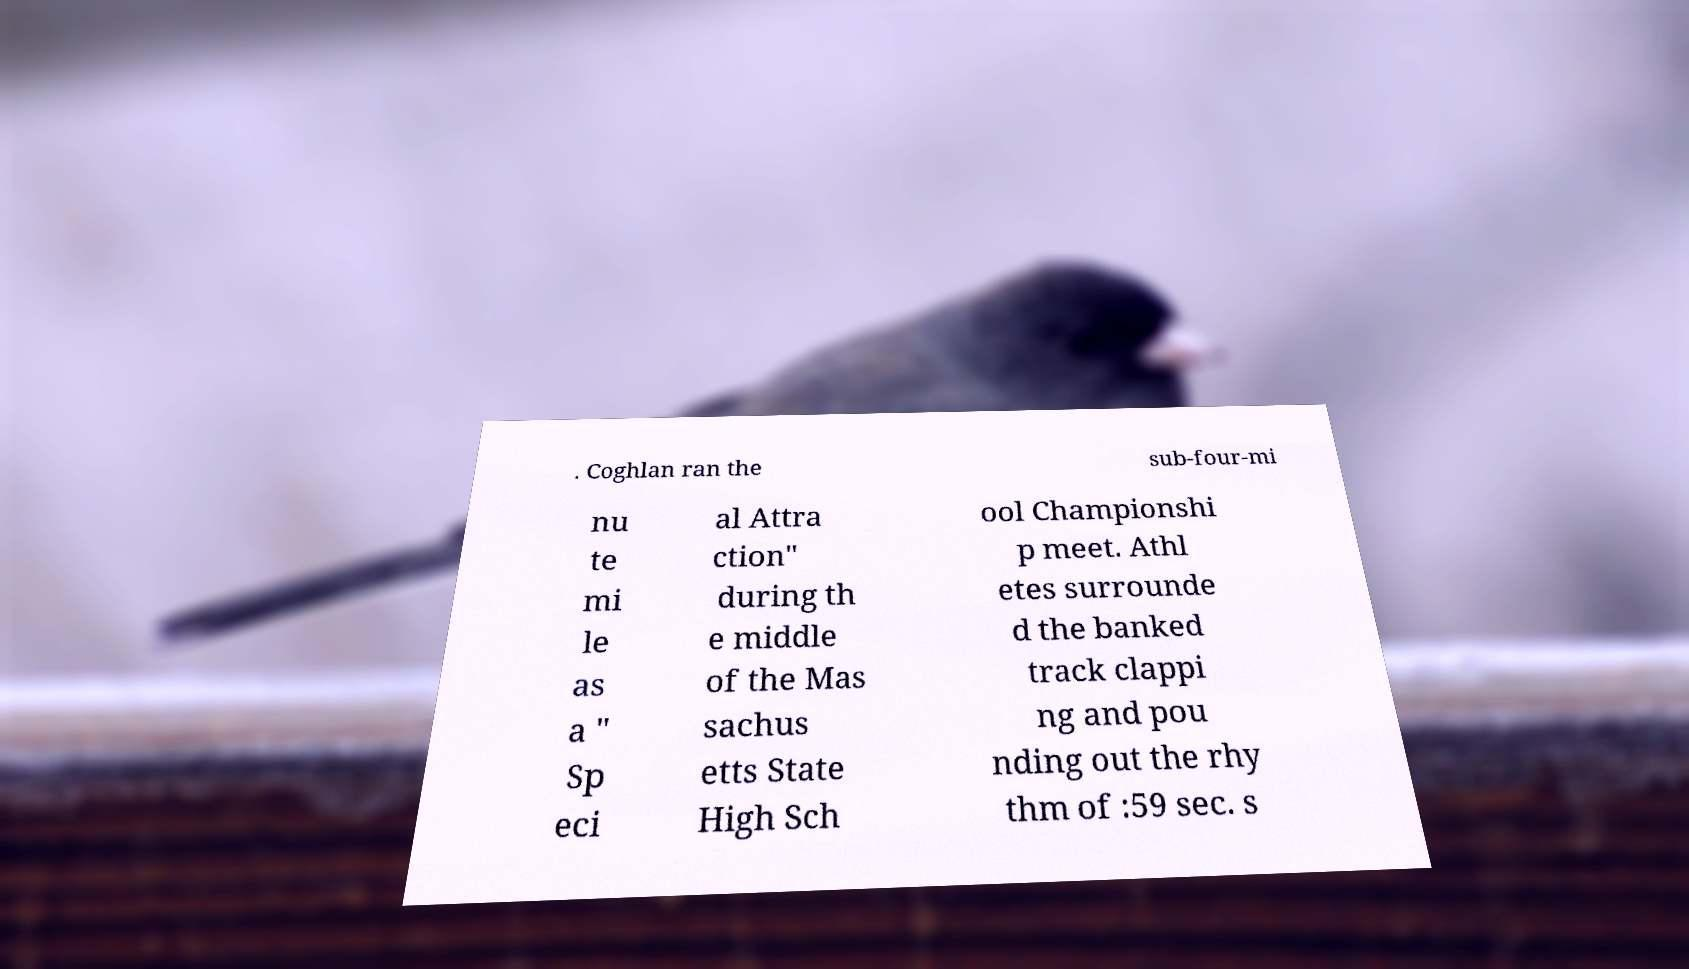For documentation purposes, I need the text within this image transcribed. Could you provide that? . Coghlan ran the sub-four-mi nu te mi le as a " Sp eci al Attra ction" during th e middle of the Mas sachus etts State High Sch ool Championshi p meet. Athl etes surrounde d the banked track clappi ng and pou nding out the rhy thm of :59 sec. s 